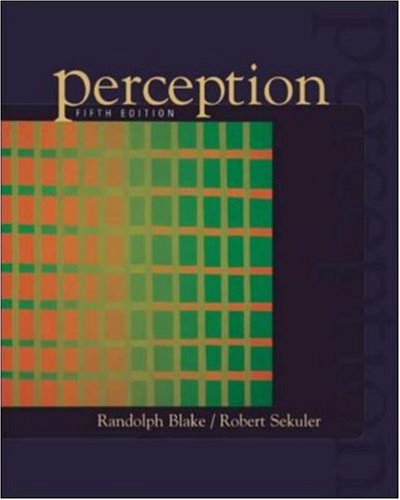What is the genre of this book? The genre of this book is best classified under Psychology, specifically focusing on cognitive and sensory processes involved in perception. 